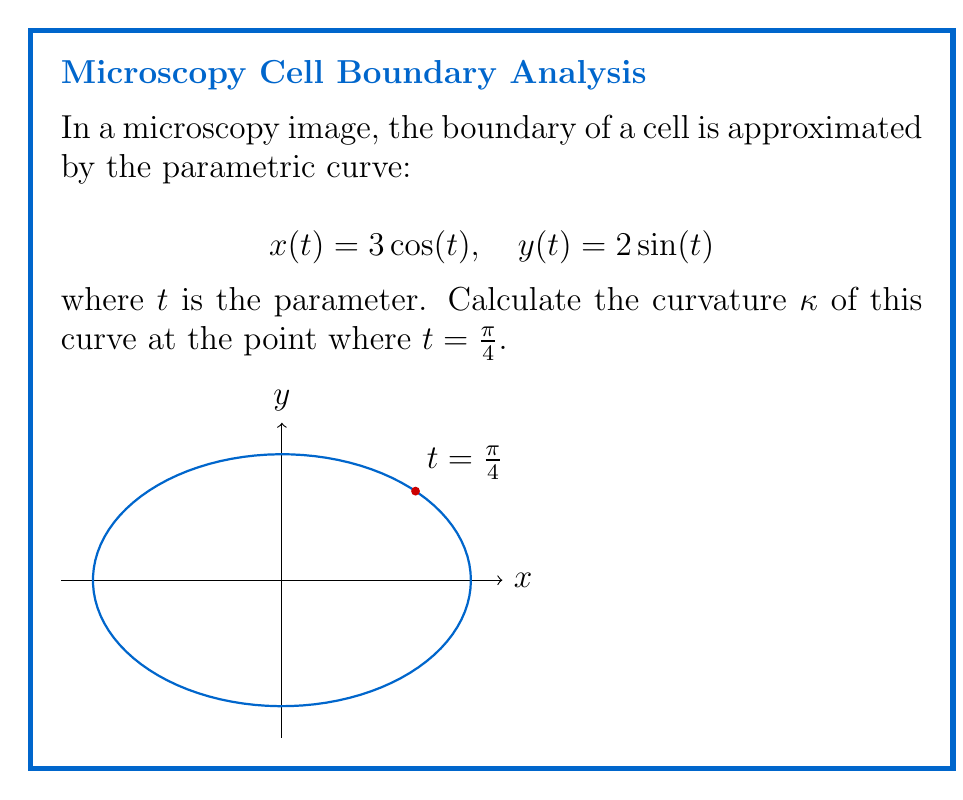What is the answer to this math problem? To calculate the curvature, we'll use the formula for parametric curves:

$$\kappa = \frac{|x'y'' - y'x''|}{(x'^2 + y'^2)^{3/2}}$$

Step 1: Calculate the first derivatives
$$x'(t) = -3\sin(t)$$
$$y'(t) = 2\cos(t)$$

Step 2: Calculate the second derivatives
$$x''(t) = -3\cos(t)$$
$$y''(t) = -2\sin(t)$$

Step 3: Evaluate the derivatives at $t = \frac{\pi}{4}$
$$x'(\frac{\pi}{4}) = -3\sin(\frac{\pi}{4}) = -\frac{3\sqrt{2}}{2}$$
$$y'(\frac{\pi}{4}) = 2\cos(\frac{\pi}{4}) = \sqrt{2}$$
$$x''(\frac{\pi}{4}) = -3\cos(\frac{\pi}{4}) = -\frac{3\sqrt{2}}{2}$$
$$y''(\frac{\pi}{4}) = -2\sin(\frac{\pi}{4}) = -\sqrt{2}$$

Step 4: Calculate the numerator of the curvature formula
$$|x'y'' - y'x''| = |-\frac{3\sqrt{2}}{2}(-\sqrt{2}) - \sqrt{2}(-\frac{3\sqrt{2}}{2})|$$
$$= |3 + 3| = 6$$

Step 5: Calculate the denominator of the curvature formula
$$(x'^2 + y'^2)^{3/2} = ((-\frac{3\sqrt{2}}{2})^2 + (\sqrt{2})^2)^{3/2}$$
$$= (\frac{9}{2} + 2)^{3/2} = (\frac{13}{2})^{3/2}$$

Step 6: Compute the final curvature
$$\kappa = \frac{6}{(\frac{13}{2})^{3/2}} = \frac{12}{13\sqrt{13}}$$
Answer: $\frac{12}{13\sqrt{13}}$ 